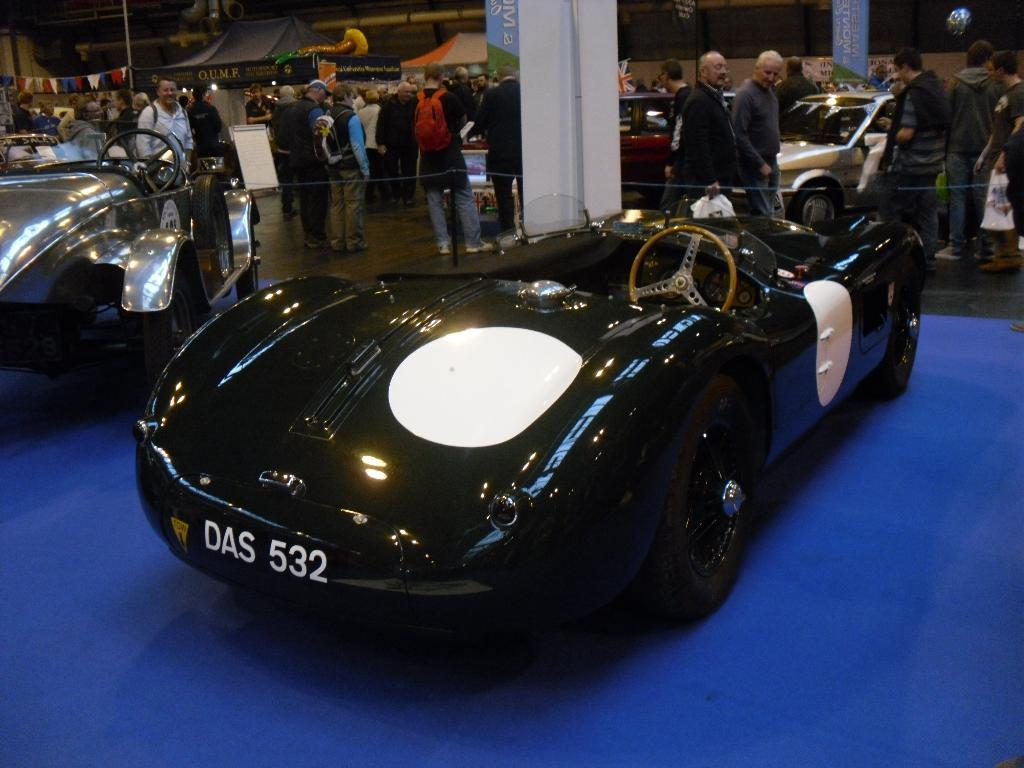What is the main subject of the image? The main subject of the image is fleets of cars. What else can be seen on the floor in the image? There is a crowd on the floor in the image. What can be seen in the background of the image? In the background, there are tents, flags, wires, pipes, and boards. Where might this image have been taken? The image may have been taken in a showroom. What type of island can be seen in the image? There is no island present in the image. How does the throat of the person in the crowd look like in the image? There is no person's throat visible in the image. 